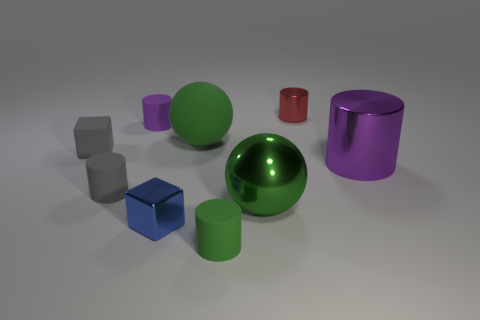Subtract all gray cylinders. How many cylinders are left? 4 Subtract all green rubber cylinders. How many cylinders are left? 4 Subtract all brown cylinders. Subtract all green balls. How many cylinders are left? 5 Add 1 big green matte balls. How many objects exist? 10 Subtract all balls. How many objects are left? 7 Subtract 0 red cubes. How many objects are left? 9 Subtract all metallic cubes. Subtract all small gray objects. How many objects are left? 6 Add 3 large cylinders. How many large cylinders are left? 4 Add 1 big brown cylinders. How many big brown cylinders exist? 1 